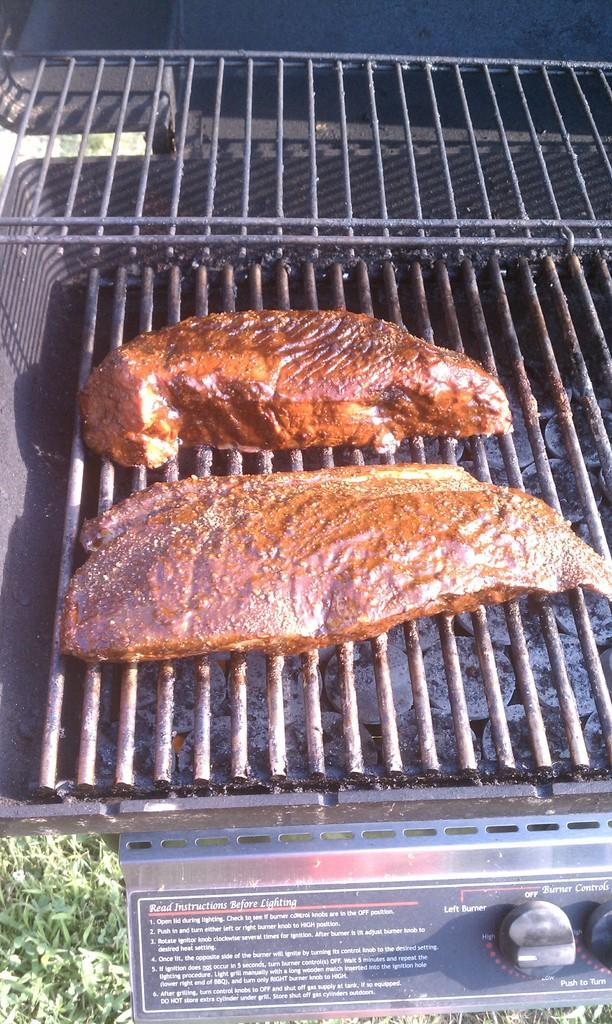<image>
Give a short and clear explanation of the subsequent image. a grill with meat on it has the instructions before lighting written on it 